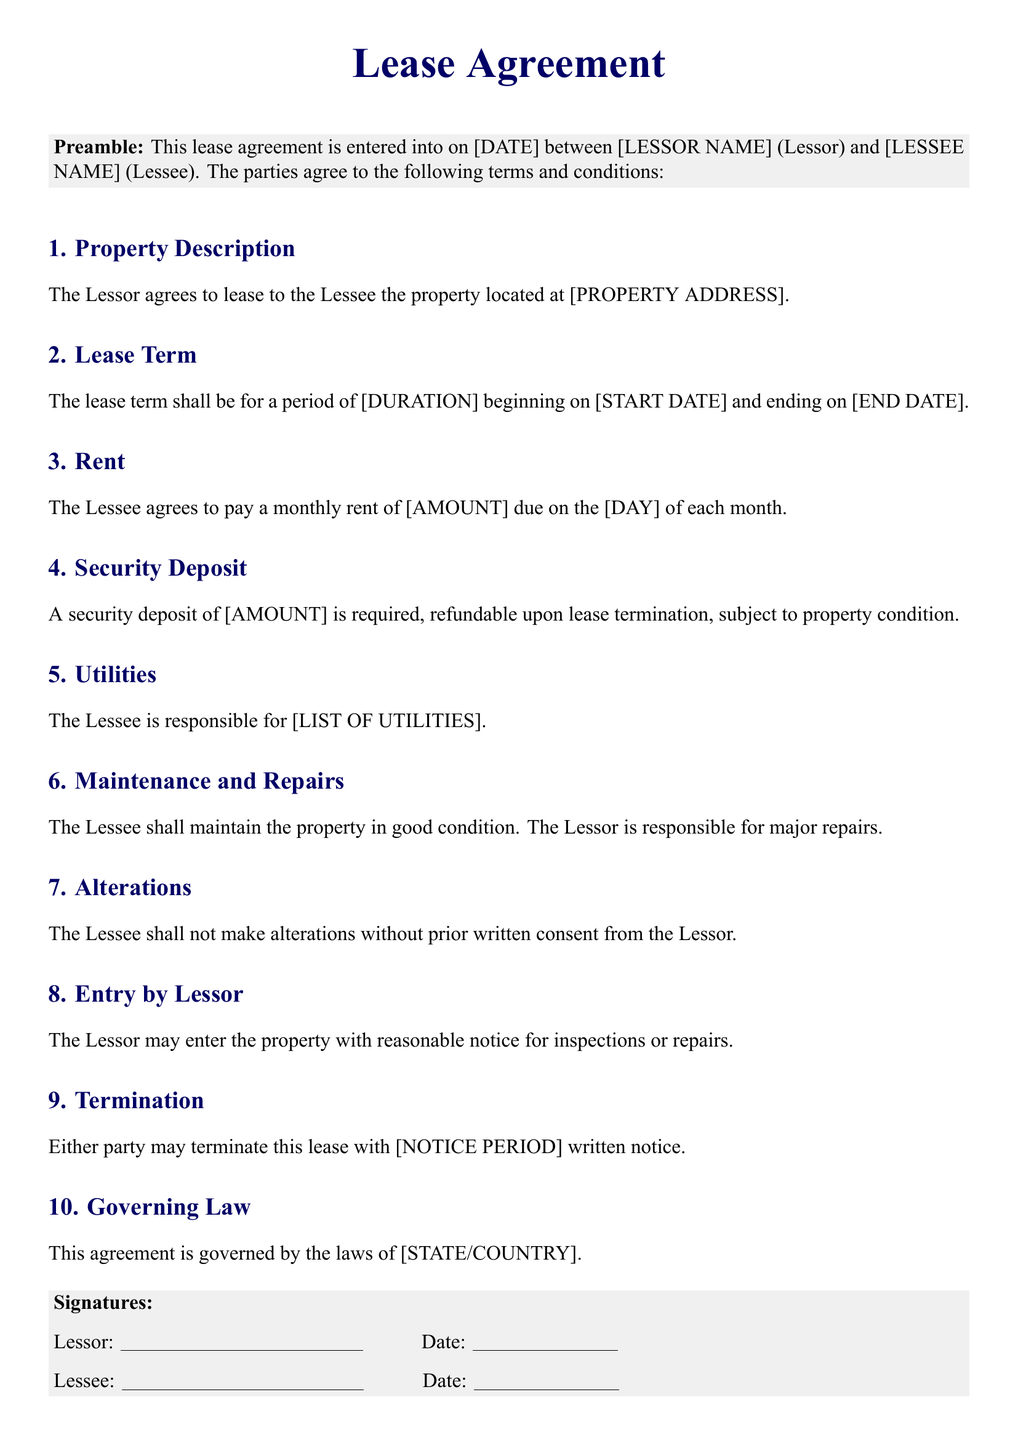What is the date of the lease agreement? The date is specified as [DATE] in the document, representing when the agreement takes effect.
Answer: [DATE] Who are the parties involved in the lease agreement? The parties specified are [LESSOR NAME] and [LESSEE NAME].
Answer: [LESSOR NAME], [LESSEE NAME] What is the lease term duration? The duration is indicated as [DURATION] in the lease term section.
Answer: [DURATION] How much is the monthly rent? The monthly rent amount is noted as [AMOUNT] in the rent section of the document.
Answer: [AMOUNT] What is the required security deposit? The document specifies a security deposit of [AMOUNT].
Answer: [AMOUNT] Who is responsible for utilities? The document indicates that the Lessee is responsible for [LIST OF UTILITIES].
Answer: [LIST OF UTILITIES] What notice period is required for termination? The notice period required for termination is specified as [NOTICE PERIOD].
Answer: [NOTICE PERIOD] What law governs this lease agreement? The governing law that applies to this agreement is indicated as [STATE/COUNTRY].
Answer: [STATE/COUNTRY] What must the Lessee do before making alterations? The Lessee must obtain prior written consent from the Lessor before making alterations.
Answer: Prior written consent What is the Lessor's obligation concerning major repairs? The Lessor is responsible for major repairs according to the maintenance clause.
Answer: Major repairs 